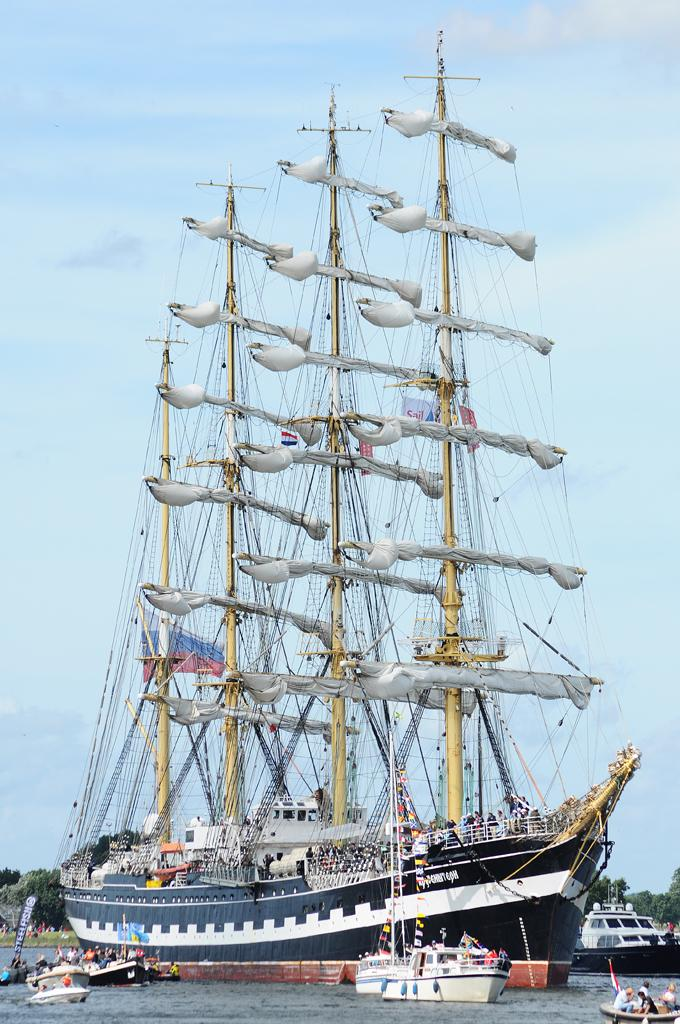<image>
Offer a succinct explanation of the picture presented. A large boat sails by smaller boats and a sign that says Steelfish. 